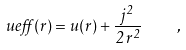<formula> <loc_0><loc_0><loc_500><loc_500>\ u e f f ( r ) = u ( r ) + \frac { j ^ { 2 } } { 2 \, r ^ { 2 } } \quad ,</formula> 